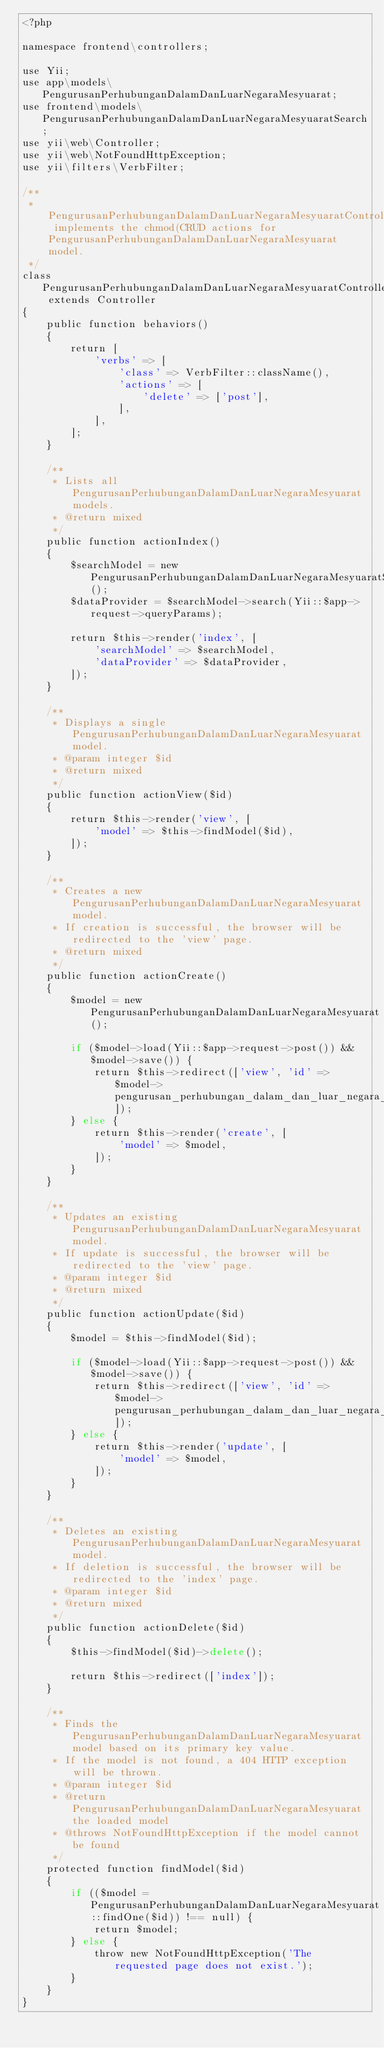<code> <loc_0><loc_0><loc_500><loc_500><_PHP_><?php

namespace frontend\controllers;

use Yii;
use app\models\PengurusanPerhubunganDalamDanLuarNegaraMesyuarat;
use frontend\models\PengurusanPerhubunganDalamDanLuarNegaraMesyuaratSearch;
use yii\web\Controller;
use yii\web\NotFoundHttpException;
use yii\filters\VerbFilter;

/**
 * PengurusanPerhubunganDalamDanLuarNegaraMesyuaratController implements the chmod(CRUD actions for PengurusanPerhubunganDalamDanLuarNegaraMesyuarat model.
 */
class PengurusanPerhubunganDalamDanLuarNegaraMesyuaratController extends Controller
{
    public function behaviors()
    {
        return [
            'verbs' => [
                'class' => VerbFilter::className(),
                'actions' => [
                    'delete' => ['post'],
                ],
            ],
        ];
    }

    /**
     * Lists all PengurusanPerhubunganDalamDanLuarNegaraMesyuarat models.
     * @return mixed
     */
    public function actionIndex()
    {
        $searchModel = new PengurusanPerhubunganDalamDanLuarNegaraMesyuaratSearch();
        $dataProvider = $searchModel->search(Yii::$app->request->queryParams);

        return $this->render('index', [
            'searchModel' => $searchModel,
            'dataProvider' => $dataProvider,
        ]);
    }

    /**
     * Displays a single PengurusanPerhubunganDalamDanLuarNegaraMesyuarat model.
     * @param integer $id
     * @return mixed
     */
    public function actionView($id)
    {
        return $this->render('view', [
            'model' => $this->findModel($id),
        ]);
    }

    /**
     * Creates a new PengurusanPerhubunganDalamDanLuarNegaraMesyuarat model.
     * If creation is successful, the browser will be redirected to the 'view' page.
     * @return mixed
     */
    public function actionCreate()
    {
        $model = new PengurusanPerhubunganDalamDanLuarNegaraMesyuarat();

        if ($model->load(Yii::$app->request->post()) && $model->save()) {
            return $this->redirect(['view', 'id' => $model->pengurusan_perhubungan_dalam_dan_luar_negara_mesyuarat_id]);
        } else {
            return $this->render('create', [
                'model' => $model,
            ]);
        }
    }

    /**
     * Updates an existing PengurusanPerhubunganDalamDanLuarNegaraMesyuarat model.
     * If update is successful, the browser will be redirected to the 'view' page.
     * @param integer $id
     * @return mixed
     */
    public function actionUpdate($id)
    {
        $model = $this->findModel($id);

        if ($model->load(Yii::$app->request->post()) && $model->save()) {
            return $this->redirect(['view', 'id' => $model->pengurusan_perhubungan_dalam_dan_luar_negara_mesyuarat_id]);
        } else {
            return $this->render('update', [
                'model' => $model,
            ]);
        }
    }

    /**
     * Deletes an existing PengurusanPerhubunganDalamDanLuarNegaraMesyuarat model.
     * If deletion is successful, the browser will be redirected to the 'index' page.
     * @param integer $id
     * @return mixed
     */
    public function actionDelete($id)
    {
        $this->findModel($id)->delete();

        return $this->redirect(['index']);
    }

    /**
     * Finds the PengurusanPerhubunganDalamDanLuarNegaraMesyuarat model based on its primary key value.
     * If the model is not found, a 404 HTTP exception will be thrown.
     * @param integer $id
     * @return PengurusanPerhubunganDalamDanLuarNegaraMesyuarat the loaded model
     * @throws NotFoundHttpException if the model cannot be found
     */
    protected function findModel($id)
    {
        if (($model = PengurusanPerhubunganDalamDanLuarNegaraMesyuarat::findOne($id)) !== null) {
            return $model;
        } else {
            throw new NotFoundHttpException('The requested page does not exist.');
        }
    }
}
</code> 